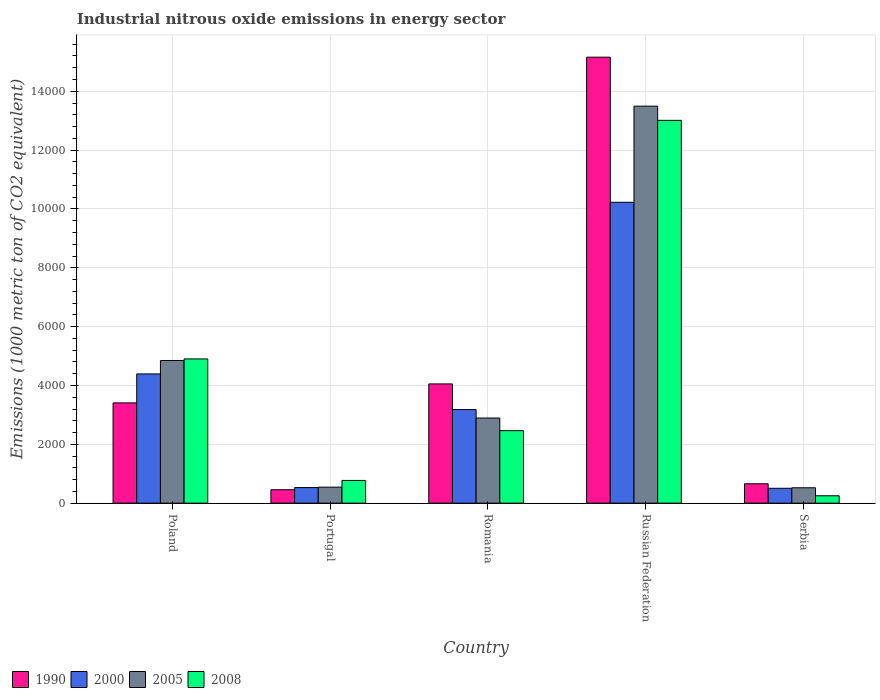How many groups of bars are there?
Provide a succinct answer. 5. Are the number of bars per tick equal to the number of legend labels?
Give a very brief answer. Yes. How many bars are there on the 5th tick from the left?
Keep it short and to the point. 4. What is the label of the 3rd group of bars from the left?
Your answer should be very brief. Romania. In how many cases, is the number of bars for a given country not equal to the number of legend labels?
Provide a succinct answer. 0. What is the amount of industrial nitrous oxide emitted in 2008 in Portugal?
Provide a short and direct response. 772.3. Across all countries, what is the maximum amount of industrial nitrous oxide emitted in 1990?
Provide a short and direct response. 1.52e+04. Across all countries, what is the minimum amount of industrial nitrous oxide emitted in 2005?
Make the answer very short. 522.3. In which country was the amount of industrial nitrous oxide emitted in 2005 maximum?
Your answer should be compact. Russian Federation. In which country was the amount of industrial nitrous oxide emitted in 2000 minimum?
Offer a terse response. Serbia. What is the total amount of industrial nitrous oxide emitted in 1990 in the graph?
Offer a terse response. 2.37e+04. What is the difference between the amount of industrial nitrous oxide emitted in 2000 in Russian Federation and that in Serbia?
Your answer should be compact. 9722.1. What is the difference between the amount of industrial nitrous oxide emitted in 1990 in Romania and the amount of industrial nitrous oxide emitted in 2000 in Portugal?
Offer a very short reply. 3523.2. What is the average amount of industrial nitrous oxide emitted in 1990 per country?
Provide a succinct answer. 4747. What is the difference between the amount of industrial nitrous oxide emitted of/in 2008 and amount of industrial nitrous oxide emitted of/in 1990 in Serbia?
Offer a very short reply. -408.1. What is the ratio of the amount of industrial nitrous oxide emitted in 2000 in Russian Federation to that in Serbia?
Give a very brief answer. 20.25. Is the difference between the amount of industrial nitrous oxide emitted in 2008 in Poland and Russian Federation greater than the difference between the amount of industrial nitrous oxide emitted in 1990 in Poland and Russian Federation?
Ensure brevity in your answer.  Yes. What is the difference between the highest and the second highest amount of industrial nitrous oxide emitted in 2008?
Ensure brevity in your answer.  8109.6. What is the difference between the highest and the lowest amount of industrial nitrous oxide emitted in 2000?
Offer a very short reply. 9722.1. In how many countries, is the amount of industrial nitrous oxide emitted in 2008 greater than the average amount of industrial nitrous oxide emitted in 2008 taken over all countries?
Offer a terse response. 2. Is the sum of the amount of industrial nitrous oxide emitted in 2008 in Poland and Romania greater than the maximum amount of industrial nitrous oxide emitted in 2000 across all countries?
Your response must be concise. No. Is it the case that in every country, the sum of the amount of industrial nitrous oxide emitted in 1990 and amount of industrial nitrous oxide emitted in 2000 is greater than the sum of amount of industrial nitrous oxide emitted in 2008 and amount of industrial nitrous oxide emitted in 2005?
Offer a very short reply. No. What does the 3rd bar from the left in Russian Federation represents?
Offer a terse response. 2005. What is the difference between two consecutive major ticks on the Y-axis?
Your response must be concise. 2000. Does the graph contain any zero values?
Keep it short and to the point. No. How are the legend labels stacked?
Offer a terse response. Horizontal. What is the title of the graph?
Offer a terse response. Industrial nitrous oxide emissions in energy sector. What is the label or title of the Y-axis?
Keep it short and to the point. Emissions (1000 metric ton of CO2 equivalent). What is the Emissions (1000 metric ton of CO2 equivalent) of 1990 in Poland?
Provide a succinct answer. 3408.2. What is the Emissions (1000 metric ton of CO2 equivalent) in 2000 in Poland?
Your answer should be compact. 4392.5. What is the Emissions (1000 metric ton of CO2 equivalent) of 2005 in Poland?
Your answer should be very brief. 4849. What is the Emissions (1000 metric ton of CO2 equivalent) of 2008 in Poland?
Your answer should be compact. 4902.7. What is the Emissions (1000 metric ton of CO2 equivalent) of 1990 in Portugal?
Ensure brevity in your answer.  456.2. What is the Emissions (1000 metric ton of CO2 equivalent) of 2000 in Portugal?
Keep it short and to the point. 529.5. What is the Emissions (1000 metric ton of CO2 equivalent) in 2005 in Portugal?
Keep it short and to the point. 543.9. What is the Emissions (1000 metric ton of CO2 equivalent) of 2008 in Portugal?
Provide a succinct answer. 772.3. What is the Emissions (1000 metric ton of CO2 equivalent) in 1990 in Romania?
Give a very brief answer. 4052.7. What is the Emissions (1000 metric ton of CO2 equivalent) in 2000 in Romania?
Your response must be concise. 3180.9. What is the Emissions (1000 metric ton of CO2 equivalent) in 2005 in Romania?
Offer a terse response. 2894.1. What is the Emissions (1000 metric ton of CO2 equivalent) of 2008 in Romania?
Your response must be concise. 2463.8. What is the Emissions (1000 metric ton of CO2 equivalent) of 1990 in Russian Federation?
Provide a short and direct response. 1.52e+04. What is the Emissions (1000 metric ton of CO2 equivalent) in 2000 in Russian Federation?
Give a very brief answer. 1.02e+04. What is the Emissions (1000 metric ton of CO2 equivalent) of 2005 in Russian Federation?
Your response must be concise. 1.35e+04. What is the Emissions (1000 metric ton of CO2 equivalent) of 2008 in Russian Federation?
Your answer should be compact. 1.30e+04. What is the Emissions (1000 metric ton of CO2 equivalent) in 1990 in Serbia?
Give a very brief answer. 658.4. What is the Emissions (1000 metric ton of CO2 equivalent) of 2000 in Serbia?
Make the answer very short. 505. What is the Emissions (1000 metric ton of CO2 equivalent) of 2005 in Serbia?
Keep it short and to the point. 522.3. What is the Emissions (1000 metric ton of CO2 equivalent) in 2008 in Serbia?
Provide a succinct answer. 250.3. Across all countries, what is the maximum Emissions (1000 metric ton of CO2 equivalent) of 1990?
Give a very brief answer. 1.52e+04. Across all countries, what is the maximum Emissions (1000 metric ton of CO2 equivalent) in 2000?
Keep it short and to the point. 1.02e+04. Across all countries, what is the maximum Emissions (1000 metric ton of CO2 equivalent) of 2005?
Keep it short and to the point. 1.35e+04. Across all countries, what is the maximum Emissions (1000 metric ton of CO2 equivalent) in 2008?
Your answer should be compact. 1.30e+04. Across all countries, what is the minimum Emissions (1000 metric ton of CO2 equivalent) of 1990?
Provide a short and direct response. 456.2. Across all countries, what is the minimum Emissions (1000 metric ton of CO2 equivalent) of 2000?
Your answer should be very brief. 505. Across all countries, what is the minimum Emissions (1000 metric ton of CO2 equivalent) of 2005?
Provide a short and direct response. 522.3. Across all countries, what is the minimum Emissions (1000 metric ton of CO2 equivalent) of 2008?
Offer a very short reply. 250.3. What is the total Emissions (1000 metric ton of CO2 equivalent) of 1990 in the graph?
Provide a succinct answer. 2.37e+04. What is the total Emissions (1000 metric ton of CO2 equivalent) in 2000 in the graph?
Your response must be concise. 1.88e+04. What is the total Emissions (1000 metric ton of CO2 equivalent) of 2005 in the graph?
Keep it short and to the point. 2.23e+04. What is the total Emissions (1000 metric ton of CO2 equivalent) in 2008 in the graph?
Keep it short and to the point. 2.14e+04. What is the difference between the Emissions (1000 metric ton of CO2 equivalent) of 1990 in Poland and that in Portugal?
Make the answer very short. 2952. What is the difference between the Emissions (1000 metric ton of CO2 equivalent) of 2000 in Poland and that in Portugal?
Your answer should be compact. 3863. What is the difference between the Emissions (1000 metric ton of CO2 equivalent) in 2005 in Poland and that in Portugal?
Offer a terse response. 4305.1. What is the difference between the Emissions (1000 metric ton of CO2 equivalent) of 2008 in Poland and that in Portugal?
Your response must be concise. 4130.4. What is the difference between the Emissions (1000 metric ton of CO2 equivalent) of 1990 in Poland and that in Romania?
Provide a short and direct response. -644.5. What is the difference between the Emissions (1000 metric ton of CO2 equivalent) in 2000 in Poland and that in Romania?
Your answer should be compact. 1211.6. What is the difference between the Emissions (1000 metric ton of CO2 equivalent) in 2005 in Poland and that in Romania?
Your answer should be compact. 1954.9. What is the difference between the Emissions (1000 metric ton of CO2 equivalent) of 2008 in Poland and that in Romania?
Make the answer very short. 2438.9. What is the difference between the Emissions (1000 metric ton of CO2 equivalent) of 1990 in Poland and that in Russian Federation?
Your answer should be very brief. -1.18e+04. What is the difference between the Emissions (1000 metric ton of CO2 equivalent) of 2000 in Poland and that in Russian Federation?
Provide a short and direct response. -5834.6. What is the difference between the Emissions (1000 metric ton of CO2 equivalent) of 2005 in Poland and that in Russian Federation?
Provide a short and direct response. -8645.6. What is the difference between the Emissions (1000 metric ton of CO2 equivalent) of 2008 in Poland and that in Russian Federation?
Offer a terse response. -8109.6. What is the difference between the Emissions (1000 metric ton of CO2 equivalent) in 1990 in Poland and that in Serbia?
Make the answer very short. 2749.8. What is the difference between the Emissions (1000 metric ton of CO2 equivalent) of 2000 in Poland and that in Serbia?
Your response must be concise. 3887.5. What is the difference between the Emissions (1000 metric ton of CO2 equivalent) of 2005 in Poland and that in Serbia?
Provide a succinct answer. 4326.7. What is the difference between the Emissions (1000 metric ton of CO2 equivalent) of 2008 in Poland and that in Serbia?
Offer a very short reply. 4652.4. What is the difference between the Emissions (1000 metric ton of CO2 equivalent) in 1990 in Portugal and that in Romania?
Make the answer very short. -3596.5. What is the difference between the Emissions (1000 metric ton of CO2 equivalent) in 2000 in Portugal and that in Romania?
Provide a short and direct response. -2651.4. What is the difference between the Emissions (1000 metric ton of CO2 equivalent) in 2005 in Portugal and that in Romania?
Ensure brevity in your answer.  -2350.2. What is the difference between the Emissions (1000 metric ton of CO2 equivalent) in 2008 in Portugal and that in Romania?
Your response must be concise. -1691.5. What is the difference between the Emissions (1000 metric ton of CO2 equivalent) of 1990 in Portugal and that in Russian Federation?
Give a very brief answer. -1.47e+04. What is the difference between the Emissions (1000 metric ton of CO2 equivalent) in 2000 in Portugal and that in Russian Federation?
Give a very brief answer. -9697.6. What is the difference between the Emissions (1000 metric ton of CO2 equivalent) in 2005 in Portugal and that in Russian Federation?
Offer a very short reply. -1.30e+04. What is the difference between the Emissions (1000 metric ton of CO2 equivalent) in 2008 in Portugal and that in Russian Federation?
Provide a short and direct response. -1.22e+04. What is the difference between the Emissions (1000 metric ton of CO2 equivalent) of 1990 in Portugal and that in Serbia?
Ensure brevity in your answer.  -202.2. What is the difference between the Emissions (1000 metric ton of CO2 equivalent) in 2000 in Portugal and that in Serbia?
Offer a very short reply. 24.5. What is the difference between the Emissions (1000 metric ton of CO2 equivalent) in 2005 in Portugal and that in Serbia?
Keep it short and to the point. 21.6. What is the difference between the Emissions (1000 metric ton of CO2 equivalent) in 2008 in Portugal and that in Serbia?
Offer a very short reply. 522. What is the difference between the Emissions (1000 metric ton of CO2 equivalent) of 1990 in Romania and that in Russian Federation?
Your response must be concise. -1.11e+04. What is the difference between the Emissions (1000 metric ton of CO2 equivalent) of 2000 in Romania and that in Russian Federation?
Your response must be concise. -7046.2. What is the difference between the Emissions (1000 metric ton of CO2 equivalent) in 2005 in Romania and that in Russian Federation?
Give a very brief answer. -1.06e+04. What is the difference between the Emissions (1000 metric ton of CO2 equivalent) of 2008 in Romania and that in Russian Federation?
Provide a succinct answer. -1.05e+04. What is the difference between the Emissions (1000 metric ton of CO2 equivalent) in 1990 in Romania and that in Serbia?
Make the answer very short. 3394.3. What is the difference between the Emissions (1000 metric ton of CO2 equivalent) in 2000 in Romania and that in Serbia?
Offer a very short reply. 2675.9. What is the difference between the Emissions (1000 metric ton of CO2 equivalent) in 2005 in Romania and that in Serbia?
Give a very brief answer. 2371.8. What is the difference between the Emissions (1000 metric ton of CO2 equivalent) in 2008 in Romania and that in Serbia?
Make the answer very short. 2213.5. What is the difference between the Emissions (1000 metric ton of CO2 equivalent) in 1990 in Russian Federation and that in Serbia?
Offer a very short reply. 1.45e+04. What is the difference between the Emissions (1000 metric ton of CO2 equivalent) of 2000 in Russian Federation and that in Serbia?
Offer a very short reply. 9722.1. What is the difference between the Emissions (1000 metric ton of CO2 equivalent) in 2005 in Russian Federation and that in Serbia?
Your answer should be compact. 1.30e+04. What is the difference between the Emissions (1000 metric ton of CO2 equivalent) in 2008 in Russian Federation and that in Serbia?
Your response must be concise. 1.28e+04. What is the difference between the Emissions (1000 metric ton of CO2 equivalent) of 1990 in Poland and the Emissions (1000 metric ton of CO2 equivalent) of 2000 in Portugal?
Make the answer very short. 2878.7. What is the difference between the Emissions (1000 metric ton of CO2 equivalent) in 1990 in Poland and the Emissions (1000 metric ton of CO2 equivalent) in 2005 in Portugal?
Offer a terse response. 2864.3. What is the difference between the Emissions (1000 metric ton of CO2 equivalent) of 1990 in Poland and the Emissions (1000 metric ton of CO2 equivalent) of 2008 in Portugal?
Keep it short and to the point. 2635.9. What is the difference between the Emissions (1000 metric ton of CO2 equivalent) in 2000 in Poland and the Emissions (1000 metric ton of CO2 equivalent) in 2005 in Portugal?
Provide a short and direct response. 3848.6. What is the difference between the Emissions (1000 metric ton of CO2 equivalent) in 2000 in Poland and the Emissions (1000 metric ton of CO2 equivalent) in 2008 in Portugal?
Give a very brief answer. 3620.2. What is the difference between the Emissions (1000 metric ton of CO2 equivalent) in 2005 in Poland and the Emissions (1000 metric ton of CO2 equivalent) in 2008 in Portugal?
Provide a succinct answer. 4076.7. What is the difference between the Emissions (1000 metric ton of CO2 equivalent) in 1990 in Poland and the Emissions (1000 metric ton of CO2 equivalent) in 2000 in Romania?
Your answer should be compact. 227.3. What is the difference between the Emissions (1000 metric ton of CO2 equivalent) of 1990 in Poland and the Emissions (1000 metric ton of CO2 equivalent) of 2005 in Romania?
Keep it short and to the point. 514.1. What is the difference between the Emissions (1000 metric ton of CO2 equivalent) in 1990 in Poland and the Emissions (1000 metric ton of CO2 equivalent) in 2008 in Romania?
Offer a very short reply. 944.4. What is the difference between the Emissions (1000 metric ton of CO2 equivalent) of 2000 in Poland and the Emissions (1000 metric ton of CO2 equivalent) of 2005 in Romania?
Provide a succinct answer. 1498.4. What is the difference between the Emissions (1000 metric ton of CO2 equivalent) of 2000 in Poland and the Emissions (1000 metric ton of CO2 equivalent) of 2008 in Romania?
Your answer should be compact. 1928.7. What is the difference between the Emissions (1000 metric ton of CO2 equivalent) of 2005 in Poland and the Emissions (1000 metric ton of CO2 equivalent) of 2008 in Romania?
Keep it short and to the point. 2385.2. What is the difference between the Emissions (1000 metric ton of CO2 equivalent) in 1990 in Poland and the Emissions (1000 metric ton of CO2 equivalent) in 2000 in Russian Federation?
Make the answer very short. -6818.9. What is the difference between the Emissions (1000 metric ton of CO2 equivalent) of 1990 in Poland and the Emissions (1000 metric ton of CO2 equivalent) of 2005 in Russian Federation?
Your answer should be compact. -1.01e+04. What is the difference between the Emissions (1000 metric ton of CO2 equivalent) in 1990 in Poland and the Emissions (1000 metric ton of CO2 equivalent) in 2008 in Russian Federation?
Provide a succinct answer. -9604.1. What is the difference between the Emissions (1000 metric ton of CO2 equivalent) of 2000 in Poland and the Emissions (1000 metric ton of CO2 equivalent) of 2005 in Russian Federation?
Your answer should be compact. -9102.1. What is the difference between the Emissions (1000 metric ton of CO2 equivalent) of 2000 in Poland and the Emissions (1000 metric ton of CO2 equivalent) of 2008 in Russian Federation?
Keep it short and to the point. -8619.8. What is the difference between the Emissions (1000 metric ton of CO2 equivalent) in 2005 in Poland and the Emissions (1000 metric ton of CO2 equivalent) in 2008 in Russian Federation?
Ensure brevity in your answer.  -8163.3. What is the difference between the Emissions (1000 metric ton of CO2 equivalent) of 1990 in Poland and the Emissions (1000 metric ton of CO2 equivalent) of 2000 in Serbia?
Give a very brief answer. 2903.2. What is the difference between the Emissions (1000 metric ton of CO2 equivalent) in 1990 in Poland and the Emissions (1000 metric ton of CO2 equivalent) in 2005 in Serbia?
Keep it short and to the point. 2885.9. What is the difference between the Emissions (1000 metric ton of CO2 equivalent) of 1990 in Poland and the Emissions (1000 metric ton of CO2 equivalent) of 2008 in Serbia?
Offer a terse response. 3157.9. What is the difference between the Emissions (1000 metric ton of CO2 equivalent) in 2000 in Poland and the Emissions (1000 metric ton of CO2 equivalent) in 2005 in Serbia?
Give a very brief answer. 3870.2. What is the difference between the Emissions (1000 metric ton of CO2 equivalent) in 2000 in Poland and the Emissions (1000 metric ton of CO2 equivalent) in 2008 in Serbia?
Your response must be concise. 4142.2. What is the difference between the Emissions (1000 metric ton of CO2 equivalent) of 2005 in Poland and the Emissions (1000 metric ton of CO2 equivalent) of 2008 in Serbia?
Offer a terse response. 4598.7. What is the difference between the Emissions (1000 metric ton of CO2 equivalent) of 1990 in Portugal and the Emissions (1000 metric ton of CO2 equivalent) of 2000 in Romania?
Provide a succinct answer. -2724.7. What is the difference between the Emissions (1000 metric ton of CO2 equivalent) in 1990 in Portugal and the Emissions (1000 metric ton of CO2 equivalent) in 2005 in Romania?
Make the answer very short. -2437.9. What is the difference between the Emissions (1000 metric ton of CO2 equivalent) in 1990 in Portugal and the Emissions (1000 metric ton of CO2 equivalent) in 2008 in Romania?
Provide a succinct answer. -2007.6. What is the difference between the Emissions (1000 metric ton of CO2 equivalent) of 2000 in Portugal and the Emissions (1000 metric ton of CO2 equivalent) of 2005 in Romania?
Offer a very short reply. -2364.6. What is the difference between the Emissions (1000 metric ton of CO2 equivalent) in 2000 in Portugal and the Emissions (1000 metric ton of CO2 equivalent) in 2008 in Romania?
Provide a short and direct response. -1934.3. What is the difference between the Emissions (1000 metric ton of CO2 equivalent) in 2005 in Portugal and the Emissions (1000 metric ton of CO2 equivalent) in 2008 in Romania?
Provide a succinct answer. -1919.9. What is the difference between the Emissions (1000 metric ton of CO2 equivalent) of 1990 in Portugal and the Emissions (1000 metric ton of CO2 equivalent) of 2000 in Russian Federation?
Offer a very short reply. -9770.9. What is the difference between the Emissions (1000 metric ton of CO2 equivalent) of 1990 in Portugal and the Emissions (1000 metric ton of CO2 equivalent) of 2005 in Russian Federation?
Make the answer very short. -1.30e+04. What is the difference between the Emissions (1000 metric ton of CO2 equivalent) of 1990 in Portugal and the Emissions (1000 metric ton of CO2 equivalent) of 2008 in Russian Federation?
Offer a terse response. -1.26e+04. What is the difference between the Emissions (1000 metric ton of CO2 equivalent) of 2000 in Portugal and the Emissions (1000 metric ton of CO2 equivalent) of 2005 in Russian Federation?
Keep it short and to the point. -1.30e+04. What is the difference between the Emissions (1000 metric ton of CO2 equivalent) in 2000 in Portugal and the Emissions (1000 metric ton of CO2 equivalent) in 2008 in Russian Federation?
Provide a succinct answer. -1.25e+04. What is the difference between the Emissions (1000 metric ton of CO2 equivalent) in 2005 in Portugal and the Emissions (1000 metric ton of CO2 equivalent) in 2008 in Russian Federation?
Provide a succinct answer. -1.25e+04. What is the difference between the Emissions (1000 metric ton of CO2 equivalent) in 1990 in Portugal and the Emissions (1000 metric ton of CO2 equivalent) in 2000 in Serbia?
Provide a succinct answer. -48.8. What is the difference between the Emissions (1000 metric ton of CO2 equivalent) in 1990 in Portugal and the Emissions (1000 metric ton of CO2 equivalent) in 2005 in Serbia?
Give a very brief answer. -66.1. What is the difference between the Emissions (1000 metric ton of CO2 equivalent) in 1990 in Portugal and the Emissions (1000 metric ton of CO2 equivalent) in 2008 in Serbia?
Ensure brevity in your answer.  205.9. What is the difference between the Emissions (1000 metric ton of CO2 equivalent) of 2000 in Portugal and the Emissions (1000 metric ton of CO2 equivalent) of 2005 in Serbia?
Provide a succinct answer. 7.2. What is the difference between the Emissions (1000 metric ton of CO2 equivalent) of 2000 in Portugal and the Emissions (1000 metric ton of CO2 equivalent) of 2008 in Serbia?
Your answer should be very brief. 279.2. What is the difference between the Emissions (1000 metric ton of CO2 equivalent) of 2005 in Portugal and the Emissions (1000 metric ton of CO2 equivalent) of 2008 in Serbia?
Offer a terse response. 293.6. What is the difference between the Emissions (1000 metric ton of CO2 equivalent) in 1990 in Romania and the Emissions (1000 metric ton of CO2 equivalent) in 2000 in Russian Federation?
Provide a succinct answer. -6174.4. What is the difference between the Emissions (1000 metric ton of CO2 equivalent) of 1990 in Romania and the Emissions (1000 metric ton of CO2 equivalent) of 2005 in Russian Federation?
Give a very brief answer. -9441.9. What is the difference between the Emissions (1000 metric ton of CO2 equivalent) in 1990 in Romania and the Emissions (1000 metric ton of CO2 equivalent) in 2008 in Russian Federation?
Give a very brief answer. -8959.6. What is the difference between the Emissions (1000 metric ton of CO2 equivalent) of 2000 in Romania and the Emissions (1000 metric ton of CO2 equivalent) of 2005 in Russian Federation?
Provide a succinct answer. -1.03e+04. What is the difference between the Emissions (1000 metric ton of CO2 equivalent) in 2000 in Romania and the Emissions (1000 metric ton of CO2 equivalent) in 2008 in Russian Federation?
Ensure brevity in your answer.  -9831.4. What is the difference between the Emissions (1000 metric ton of CO2 equivalent) of 2005 in Romania and the Emissions (1000 metric ton of CO2 equivalent) of 2008 in Russian Federation?
Provide a succinct answer. -1.01e+04. What is the difference between the Emissions (1000 metric ton of CO2 equivalent) in 1990 in Romania and the Emissions (1000 metric ton of CO2 equivalent) in 2000 in Serbia?
Your answer should be compact. 3547.7. What is the difference between the Emissions (1000 metric ton of CO2 equivalent) in 1990 in Romania and the Emissions (1000 metric ton of CO2 equivalent) in 2005 in Serbia?
Ensure brevity in your answer.  3530.4. What is the difference between the Emissions (1000 metric ton of CO2 equivalent) of 1990 in Romania and the Emissions (1000 metric ton of CO2 equivalent) of 2008 in Serbia?
Provide a succinct answer. 3802.4. What is the difference between the Emissions (1000 metric ton of CO2 equivalent) in 2000 in Romania and the Emissions (1000 metric ton of CO2 equivalent) in 2005 in Serbia?
Keep it short and to the point. 2658.6. What is the difference between the Emissions (1000 metric ton of CO2 equivalent) of 2000 in Romania and the Emissions (1000 metric ton of CO2 equivalent) of 2008 in Serbia?
Provide a succinct answer. 2930.6. What is the difference between the Emissions (1000 metric ton of CO2 equivalent) of 2005 in Romania and the Emissions (1000 metric ton of CO2 equivalent) of 2008 in Serbia?
Offer a very short reply. 2643.8. What is the difference between the Emissions (1000 metric ton of CO2 equivalent) in 1990 in Russian Federation and the Emissions (1000 metric ton of CO2 equivalent) in 2000 in Serbia?
Offer a terse response. 1.47e+04. What is the difference between the Emissions (1000 metric ton of CO2 equivalent) of 1990 in Russian Federation and the Emissions (1000 metric ton of CO2 equivalent) of 2005 in Serbia?
Your response must be concise. 1.46e+04. What is the difference between the Emissions (1000 metric ton of CO2 equivalent) of 1990 in Russian Federation and the Emissions (1000 metric ton of CO2 equivalent) of 2008 in Serbia?
Your response must be concise. 1.49e+04. What is the difference between the Emissions (1000 metric ton of CO2 equivalent) in 2000 in Russian Federation and the Emissions (1000 metric ton of CO2 equivalent) in 2005 in Serbia?
Ensure brevity in your answer.  9704.8. What is the difference between the Emissions (1000 metric ton of CO2 equivalent) of 2000 in Russian Federation and the Emissions (1000 metric ton of CO2 equivalent) of 2008 in Serbia?
Provide a succinct answer. 9976.8. What is the difference between the Emissions (1000 metric ton of CO2 equivalent) of 2005 in Russian Federation and the Emissions (1000 metric ton of CO2 equivalent) of 2008 in Serbia?
Provide a succinct answer. 1.32e+04. What is the average Emissions (1000 metric ton of CO2 equivalent) in 1990 per country?
Your response must be concise. 4747. What is the average Emissions (1000 metric ton of CO2 equivalent) of 2000 per country?
Offer a terse response. 3767. What is the average Emissions (1000 metric ton of CO2 equivalent) of 2005 per country?
Offer a very short reply. 4460.78. What is the average Emissions (1000 metric ton of CO2 equivalent) in 2008 per country?
Your response must be concise. 4280.28. What is the difference between the Emissions (1000 metric ton of CO2 equivalent) in 1990 and Emissions (1000 metric ton of CO2 equivalent) in 2000 in Poland?
Provide a succinct answer. -984.3. What is the difference between the Emissions (1000 metric ton of CO2 equivalent) of 1990 and Emissions (1000 metric ton of CO2 equivalent) of 2005 in Poland?
Give a very brief answer. -1440.8. What is the difference between the Emissions (1000 metric ton of CO2 equivalent) in 1990 and Emissions (1000 metric ton of CO2 equivalent) in 2008 in Poland?
Provide a short and direct response. -1494.5. What is the difference between the Emissions (1000 metric ton of CO2 equivalent) in 2000 and Emissions (1000 metric ton of CO2 equivalent) in 2005 in Poland?
Give a very brief answer. -456.5. What is the difference between the Emissions (1000 metric ton of CO2 equivalent) of 2000 and Emissions (1000 metric ton of CO2 equivalent) of 2008 in Poland?
Your response must be concise. -510.2. What is the difference between the Emissions (1000 metric ton of CO2 equivalent) in 2005 and Emissions (1000 metric ton of CO2 equivalent) in 2008 in Poland?
Ensure brevity in your answer.  -53.7. What is the difference between the Emissions (1000 metric ton of CO2 equivalent) in 1990 and Emissions (1000 metric ton of CO2 equivalent) in 2000 in Portugal?
Offer a very short reply. -73.3. What is the difference between the Emissions (1000 metric ton of CO2 equivalent) in 1990 and Emissions (1000 metric ton of CO2 equivalent) in 2005 in Portugal?
Your response must be concise. -87.7. What is the difference between the Emissions (1000 metric ton of CO2 equivalent) in 1990 and Emissions (1000 metric ton of CO2 equivalent) in 2008 in Portugal?
Ensure brevity in your answer.  -316.1. What is the difference between the Emissions (1000 metric ton of CO2 equivalent) in 2000 and Emissions (1000 metric ton of CO2 equivalent) in 2005 in Portugal?
Offer a very short reply. -14.4. What is the difference between the Emissions (1000 metric ton of CO2 equivalent) in 2000 and Emissions (1000 metric ton of CO2 equivalent) in 2008 in Portugal?
Provide a succinct answer. -242.8. What is the difference between the Emissions (1000 metric ton of CO2 equivalent) of 2005 and Emissions (1000 metric ton of CO2 equivalent) of 2008 in Portugal?
Your answer should be compact. -228.4. What is the difference between the Emissions (1000 metric ton of CO2 equivalent) of 1990 and Emissions (1000 metric ton of CO2 equivalent) of 2000 in Romania?
Offer a terse response. 871.8. What is the difference between the Emissions (1000 metric ton of CO2 equivalent) in 1990 and Emissions (1000 metric ton of CO2 equivalent) in 2005 in Romania?
Give a very brief answer. 1158.6. What is the difference between the Emissions (1000 metric ton of CO2 equivalent) in 1990 and Emissions (1000 metric ton of CO2 equivalent) in 2008 in Romania?
Your answer should be compact. 1588.9. What is the difference between the Emissions (1000 metric ton of CO2 equivalent) in 2000 and Emissions (1000 metric ton of CO2 equivalent) in 2005 in Romania?
Keep it short and to the point. 286.8. What is the difference between the Emissions (1000 metric ton of CO2 equivalent) in 2000 and Emissions (1000 metric ton of CO2 equivalent) in 2008 in Romania?
Ensure brevity in your answer.  717.1. What is the difference between the Emissions (1000 metric ton of CO2 equivalent) of 2005 and Emissions (1000 metric ton of CO2 equivalent) of 2008 in Romania?
Provide a succinct answer. 430.3. What is the difference between the Emissions (1000 metric ton of CO2 equivalent) of 1990 and Emissions (1000 metric ton of CO2 equivalent) of 2000 in Russian Federation?
Your answer should be compact. 4932.4. What is the difference between the Emissions (1000 metric ton of CO2 equivalent) of 1990 and Emissions (1000 metric ton of CO2 equivalent) of 2005 in Russian Federation?
Your response must be concise. 1664.9. What is the difference between the Emissions (1000 metric ton of CO2 equivalent) in 1990 and Emissions (1000 metric ton of CO2 equivalent) in 2008 in Russian Federation?
Your answer should be compact. 2147.2. What is the difference between the Emissions (1000 metric ton of CO2 equivalent) of 2000 and Emissions (1000 metric ton of CO2 equivalent) of 2005 in Russian Federation?
Your answer should be compact. -3267.5. What is the difference between the Emissions (1000 metric ton of CO2 equivalent) in 2000 and Emissions (1000 metric ton of CO2 equivalent) in 2008 in Russian Federation?
Your response must be concise. -2785.2. What is the difference between the Emissions (1000 metric ton of CO2 equivalent) of 2005 and Emissions (1000 metric ton of CO2 equivalent) of 2008 in Russian Federation?
Offer a very short reply. 482.3. What is the difference between the Emissions (1000 metric ton of CO2 equivalent) of 1990 and Emissions (1000 metric ton of CO2 equivalent) of 2000 in Serbia?
Provide a succinct answer. 153.4. What is the difference between the Emissions (1000 metric ton of CO2 equivalent) in 1990 and Emissions (1000 metric ton of CO2 equivalent) in 2005 in Serbia?
Your answer should be compact. 136.1. What is the difference between the Emissions (1000 metric ton of CO2 equivalent) in 1990 and Emissions (1000 metric ton of CO2 equivalent) in 2008 in Serbia?
Offer a terse response. 408.1. What is the difference between the Emissions (1000 metric ton of CO2 equivalent) of 2000 and Emissions (1000 metric ton of CO2 equivalent) of 2005 in Serbia?
Offer a terse response. -17.3. What is the difference between the Emissions (1000 metric ton of CO2 equivalent) in 2000 and Emissions (1000 metric ton of CO2 equivalent) in 2008 in Serbia?
Provide a succinct answer. 254.7. What is the difference between the Emissions (1000 metric ton of CO2 equivalent) in 2005 and Emissions (1000 metric ton of CO2 equivalent) in 2008 in Serbia?
Offer a terse response. 272. What is the ratio of the Emissions (1000 metric ton of CO2 equivalent) in 1990 in Poland to that in Portugal?
Provide a succinct answer. 7.47. What is the ratio of the Emissions (1000 metric ton of CO2 equivalent) of 2000 in Poland to that in Portugal?
Make the answer very short. 8.3. What is the ratio of the Emissions (1000 metric ton of CO2 equivalent) in 2005 in Poland to that in Portugal?
Keep it short and to the point. 8.92. What is the ratio of the Emissions (1000 metric ton of CO2 equivalent) of 2008 in Poland to that in Portugal?
Offer a very short reply. 6.35. What is the ratio of the Emissions (1000 metric ton of CO2 equivalent) in 1990 in Poland to that in Romania?
Your response must be concise. 0.84. What is the ratio of the Emissions (1000 metric ton of CO2 equivalent) of 2000 in Poland to that in Romania?
Provide a succinct answer. 1.38. What is the ratio of the Emissions (1000 metric ton of CO2 equivalent) of 2005 in Poland to that in Romania?
Offer a very short reply. 1.68. What is the ratio of the Emissions (1000 metric ton of CO2 equivalent) of 2008 in Poland to that in Romania?
Provide a succinct answer. 1.99. What is the ratio of the Emissions (1000 metric ton of CO2 equivalent) in 1990 in Poland to that in Russian Federation?
Give a very brief answer. 0.22. What is the ratio of the Emissions (1000 metric ton of CO2 equivalent) in 2000 in Poland to that in Russian Federation?
Your response must be concise. 0.43. What is the ratio of the Emissions (1000 metric ton of CO2 equivalent) in 2005 in Poland to that in Russian Federation?
Ensure brevity in your answer.  0.36. What is the ratio of the Emissions (1000 metric ton of CO2 equivalent) of 2008 in Poland to that in Russian Federation?
Keep it short and to the point. 0.38. What is the ratio of the Emissions (1000 metric ton of CO2 equivalent) of 1990 in Poland to that in Serbia?
Your answer should be very brief. 5.18. What is the ratio of the Emissions (1000 metric ton of CO2 equivalent) in 2000 in Poland to that in Serbia?
Your answer should be compact. 8.7. What is the ratio of the Emissions (1000 metric ton of CO2 equivalent) in 2005 in Poland to that in Serbia?
Ensure brevity in your answer.  9.28. What is the ratio of the Emissions (1000 metric ton of CO2 equivalent) of 2008 in Poland to that in Serbia?
Give a very brief answer. 19.59. What is the ratio of the Emissions (1000 metric ton of CO2 equivalent) of 1990 in Portugal to that in Romania?
Keep it short and to the point. 0.11. What is the ratio of the Emissions (1000 metric ton of CO2 equivalent) of 2000 in Portugal to that in Romania?
Your response must be concise. 0.17. What is the ratio of the Emissions (1000 metric ton of CO2 equivalent) in 2005 in Portugal to that in Romania?
Provide a short and direct response. 0.19. What is the ratio of the Emissions (1000 metric ton of CO2 equivalent) of 2008 in Portugal to that in Romania?
Give a very brief answer. 0.31. What is the ratio of the Emissions (1000 metric ton of CO2 equivalent) in 1990 in Portugal to that in Russian Federation?
Ensure brevity in your answer.  0.03. What is the ratio of the Emissions (1000 metric ton of CO2 equivalent) of 2000 in Portugal to that in Russian Federation?
Ensure brevity in your answer.  0.05. What is the ratio of the Emissions (1000 metric ton of CO2 equivalent) in 2005 in Portugal to that in Russian Federation?
Make the answer very short. 0.04. What is the ratio of the Emissions (1000 metric ton of CO2 equivalent) of 2008 in Portugal to that in Russian Federation?
Keep it short and to the point. 0.06. What is the ratio of the Emissions (1000 metric ton of CO2 equivalent) of 1990 in Portugal to that in Serbia?
Provide a succinct answer. 0.69. What is the ratio of the Emissions (1000 metric ton of CO2 equivalent) in 2000 in Portugal to that in Serbia?
Your answer should be compact. 1.05. What is the ratio of the Emissions (1000 metric ton of CO2 equivalent) in 2005 in Portugal to that in Serbia?
Give a very brief answer. 1.04. What is the ratio of the Emissions (1000 metric ton of CO2 equivalent) of 2008 in Portugal to that in Serbia?
Give a very brief answer. 3.09. What is the ratio of the Emissions (1000 metric ton of CO2 equivalent) of 1990 in Romania to that in Russian Federation?
Give a very brief answer. 0.27. What is the ratio of the Emissions (1000 metric ton of CO2 equivalent) of 2000 in Romania to that in Russian Federation?
Ensure brevity in your answer.  0.31. What is the ratio of the Emissions (1000 metric ton of CO2 equivalent) of 2005 in Romania to that in Russian Federation?
Your response must be concise. 0.21. What is the ratio of the Emissions (1000 metric ton of CO2 equivalent) in 2008 in Romania to that in Russian Federation?
Offer a very short reply. 0.19. What is the ratio of the Emissions (1000 metric ton of CO2 equivalent) of 1990 in Romania to that in Serbia?
Provide a short and direct response. 6.16. What is the ratio of the Emissions (1000 metric ton of CO2 equivalent) in 2000 in Romania to that in Serbia?
Make the answer very short. 6.3. What is the ratio of the Emissions (1000 metric ton of CO2 equivalent) of 2005 in Romania to that in Serbia?
Offer a very short reply. 5.54. What is the ratio of the Emissions (1000 metric ton of CO2 equivalent) in 2008 in Romania to that in Serbia?
Your response must be concise. 9.84. What is the ratio of the Emissions (1000 metric ton of CO2 equivalent) of 1990 in Russian Federation to that in Serbia?
Provide a succinct answer. 23.02. What is the ratio of the Emissions (1000 metric ton of CO2 equivalent) in 2000 in Russian Federation to that in Serbia?
Your answer should be very brief. 20.25. What is the ratio of the Emissions (1000 metric ton of CO2 equivalent) in 2005 in Russian Federation to that in Serbia?
Keep it short and to the point. 25.84. What is the ratio of the Emissions (1000 metric ton of CO2 equivalent) in 2008 in Russian Federation to that in Serbia?
Your answer should be compact. 51.99. What is the difference between the highest and the second highest Emissions (1000 metric ton of CO2 equivalent) in 1990?
Offer a very short reply. 1.11e+04. What is the difference between the highest and the second highest Emissions (1000 metric ton of CO2 equivalent) of 2000?
Ensure brevity in your answer.  5834.6. What is the difference between the highest and the second highest Emissions (1000 metric ton of CO2 equivalent) of 2005?
Your answer should be very brief. 8645.6. What is the difference between the highest and the second highest Emissions (1000 metric ton of CO2 equivalent) in 2008?
Make the answer very short. 8109.6. What is the difference between the highest and the lowest Emissions (1000 metric ton of CO2 equivalent) of 1990?
Provide a succinct answer. 1.47e+04. What is the difference between the highest and the lowest Emissions (1000 metric ton of CO2 equivalent) of 2000?
Your answer should be compact. 9722.1. What is the difference between the highest and the lowest Emissions (1000 metric ton of CO2 equivalent) of 2005?
Provide a short and direct response. 1.30e+04. What is the difference between the highest and the lowest Emissions (1000 metric ton of CO2 equivalent) in 2008?
Your answer should be compact. 1.28e+04. 